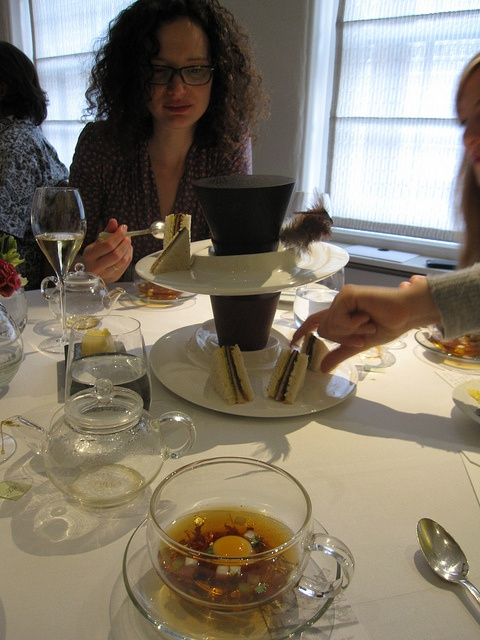Describe the objects in this image and their specific colors. I can see dining table in black, gray, and tan tones, people in black, maroon, and gray tones, cup in black, tan, maroon, and olive tones, people in black, maroon, and gray tones, and people in black and gray tones in this image. 